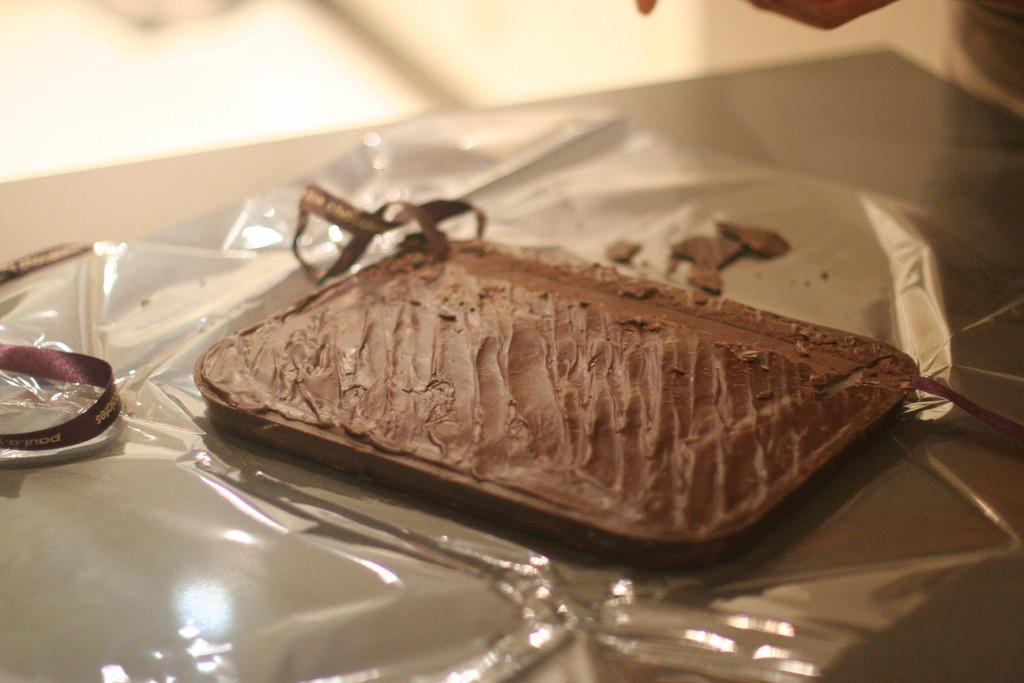What is the main subject of the image? There is a food item on a cover in the image. Where is the cover located? The cover is on a table. What other items can be seen near the food item? There are ribbons beside the food item in the image. Can you describe the wave pattern on the quilt in the image? There is no quilt or wave pattern present in the image. How many geese are visible in the image? There are no geese present in the image. 